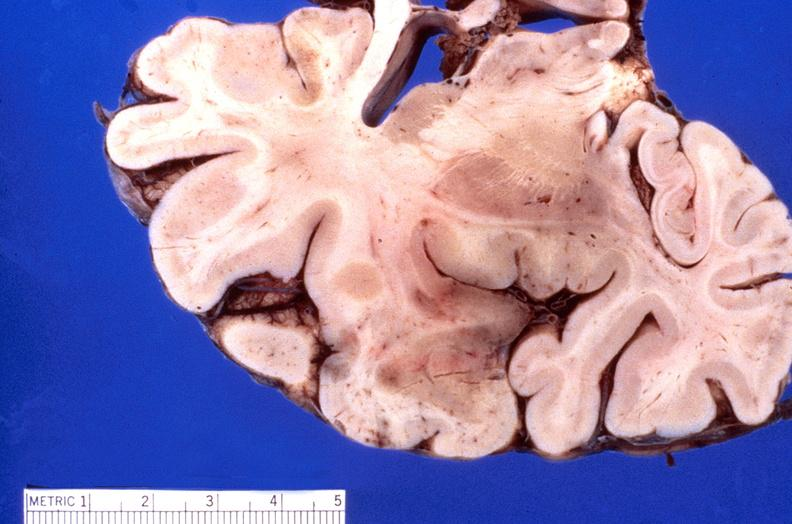what is present?
Answer the question using a single word or phrase. Nervous 